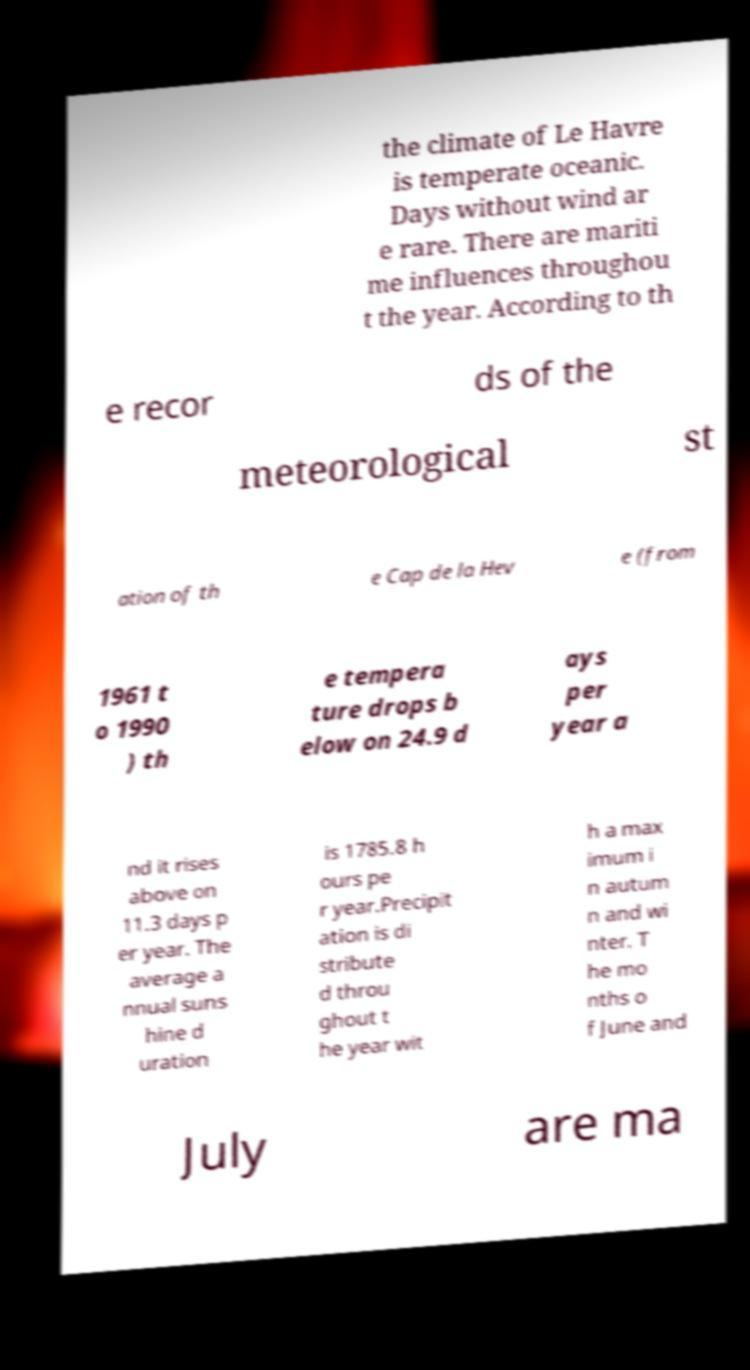Please identify and transcribe the text found in this image. the climate of Le Havre is temperate oceanic. Days without wind ar e rare. There are mariti me influences throughou t the year. According to th e recor ds of the meteorological st ation of th e Cap de la Hev e (from 1961 t o 1990 ) th e tempera ture drops b elow on 24.9 d ays per year a nd it rises above on 11.3 days p er year. The average a nnual suns hine d uration is 1785.8 h ours pe r year.Precipit ation is di stribute d throu ghout t he year wit h a max imum i n autum n and wi nter. T he mo nths o f June and July are ma 